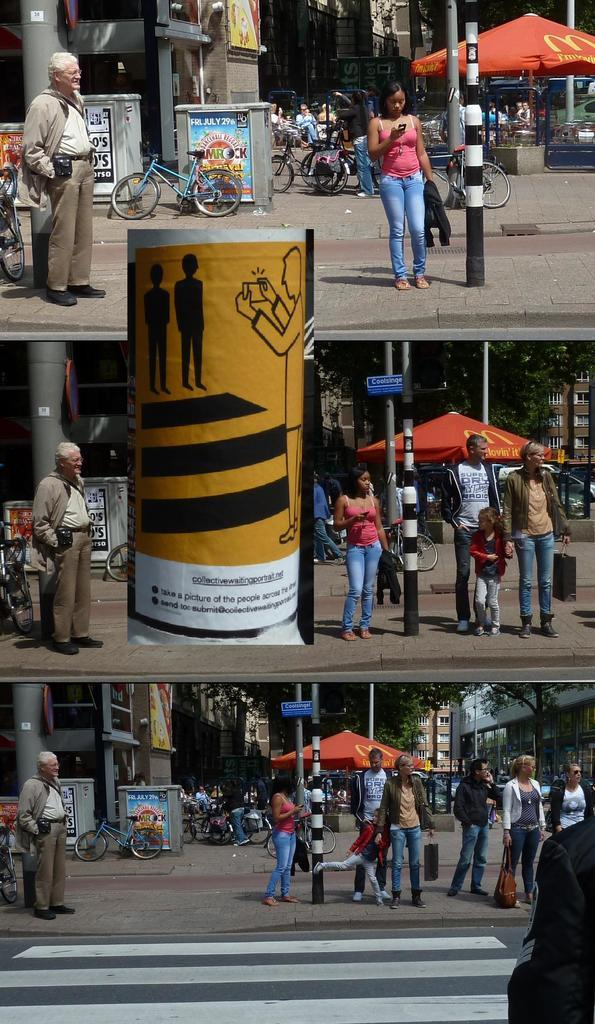<image>
Provide a brief description of the given image. A city street with numerous people and an advertisement for Jamrock on Friday July 29th. 